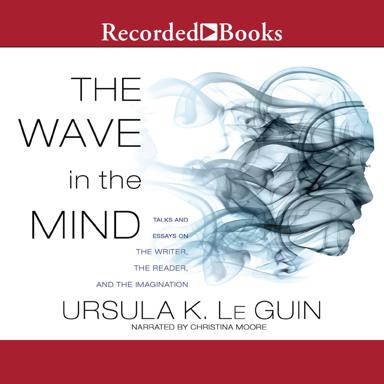Who is the narrator of the audiobook version? The audiobook version of 'The Wave in the Mind' is adeptly narrated by Christina Moore, who brings an engaging voice and nuanced delivery to Ursula K. Le Guin's deep and thoughtful essays. 